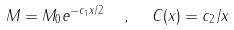Convert formula to latex. <formula><loc_0><loc_0><loc_500><loc_500>M = M _ { 0 } e ^ { - c _ { 1 } x / 2 } \ \ , \ \ C ( x ) = c _ { 2 } / x</formula> 